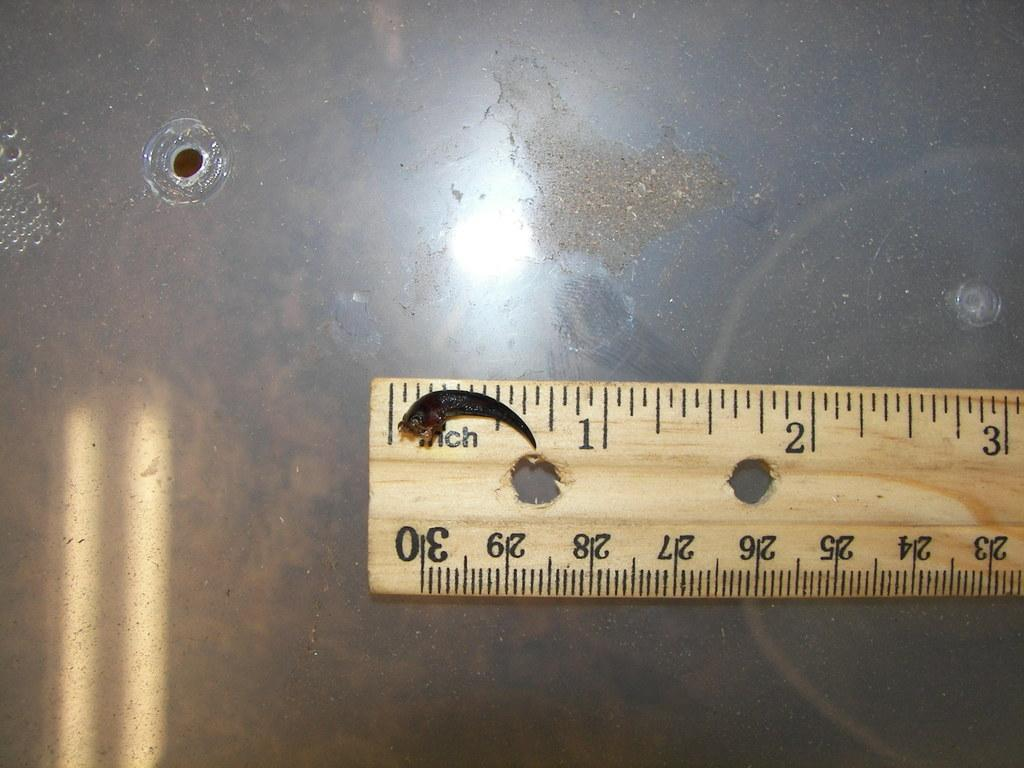<image>
Relay a brief, clear account of the picture shown. A ruler that shows 3 inches is next to a hole in the surface 